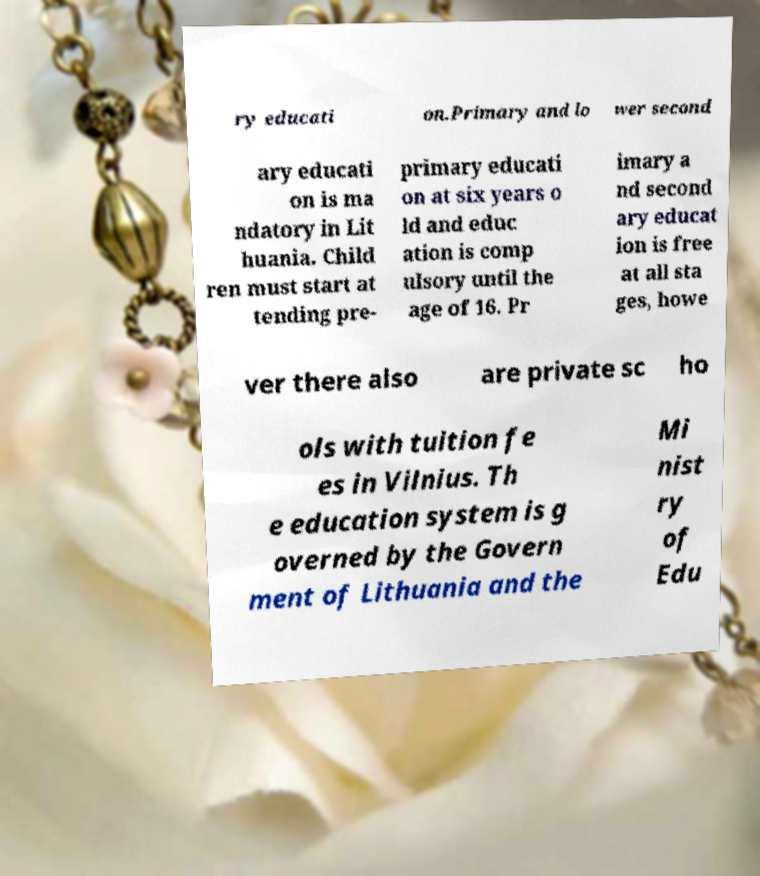Can you accurately transcribe the text from the provided image for me? ry educati on.Primary and lo wer second ary educati on is ma ndatory in Lit huania. Child ren must start at tending pre- primary educati on at six years o ld and educ ation is comp ulsory until the age of 16. Pr imary a nd second ary educat ion is free at all sta ges, howe ver there also are private sc ho ols with tuition fe es in Vilnius. Th e education system is g overned by the Govern ment of Lithuania and the Mi nist ry of Edu 